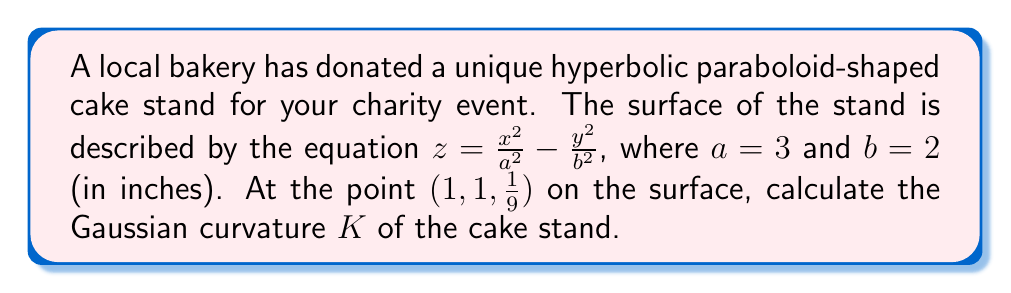What is the answer to this math problem? To find the Gaussian curvature $K$ of the hyperbolic paraboloid at the given point, we'll follow these steps:

1) The general form of a hyperbolic paraboloid is $z = \frac{x^2}{a^2} - \frac{y^2}{b^2}$. Here, $a = 3$ and $b = 2$.

2) The Gaussian curvature $K$ for a surface $z = f(x,y)$ is given by:

   $$K = \frac{f_{xx}f_{yy} - f_{xy}^2}{(1 + f_x^2 + f_y^2)^2}$$

   where subscripts denote partial derivatives.

3) Calculate the partial derivatives:
   
   $f_x = \frac{2x}{a^2} = \frac{2x}{9}$
   
   $f_y = -\frac{2y}{b^2} = -\frac{y}{2}$
   
   $f_{xx} = \frac{2}{a^2} = \frac{2}{9}$
   
   $f_{yy} = -\frac{2}{b^2} = -\frac{1}{2}$
   
   $f_{xy} = 0$

4) Substitute these into the formula for $K$:

   $$K = \frac{(\frac{2}{9})(-\frac{1}{2}) - 0^2}{(1 + (\frac{2x}{9})^2 + (-\frac{y}{2})^2)^2}$$

5) At the point $(1, 1, \frac{1}{9})$, substitute $x = 1$ and $y = 1$:

   $$K = \frac{-\frac{1}{9}}{(1 + (\frac{2}{9})^2 + (-\frac{1}{2})^2)^2}$$

6) Simplify:

   $$K = \frac{-\frac{1}{9}}{(1 + \frac{4}{81} + \frac{1}{4})^2} = \frac{-\frac{1}{9}}{(\frac{81}{81} + \frac{4}{81} + \frac{20}{81})^2} = \frac{-\frac{1}{9}}{(\frac{105}{81})^2}$$

7) Calculate the final value:

   $$K = -\frac{81}{9 \cdot 105^2} = -\frac{1}{1157.625} \approx -0.000864$$
Answer: $K \approx -0.000864$ in$^{-2}$ 